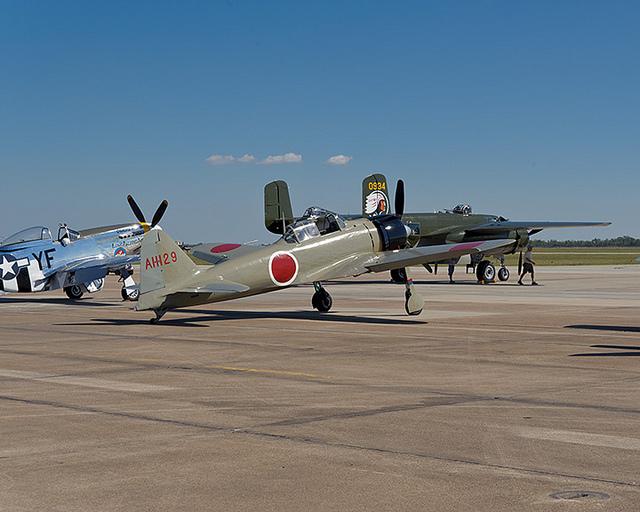What is the number on the back of the airplane?
Give a very brief answer. 29. What number is on the airplane?
Give a very brief answer. 29. Is it cloudy?
Be succinct. No. What shape is on the front plane?
Keep it brief. Circle. Where are the smallest wheels located?
Concise answer only. Back. How many planes are there?
Quick response, please. 3. What is the weather in this scene?
Answer briefly. Sunny. What color is the middle plane?
Quick response, please. Gray. Do both planes have propellers?
Answer briefly. Yes. Is the photo colored?
Short answer required. Yes. What type of plain is this?
Concise answer only. Fighter plane. Is the plane facing toward the camera?
Give a very brief answer. No. How many wheels are touching the pavement?
Quick response, please. 9. Is this airplane safe?
Concise answer only. Yes. What is being used to prevent the wheels of the plane from rolling?
Be succinct. Brakes. Are all the planes the same model?
Keep it brief. No. How large is the plane?
Concise answer only. Small. What does the sky look like?
Give a very brief answer. Clear. Is the plane in flight?
Give a very brief answer. No. What branch of the service is depicted?
Write a very short answer. Air force. Does the weather look bad enough to ground the planes?
Quick response, please. No. How many parts are red?
Give a very brief answer. 1. What is the propeller doing?
Be succinct. Nothing. How many airplanes are there in this image?
Write a very short answer. 3. Is this a prop plane?
Be succinct. No. What three colors are on the airplanes tail?
Answer briefly. Green red white. 